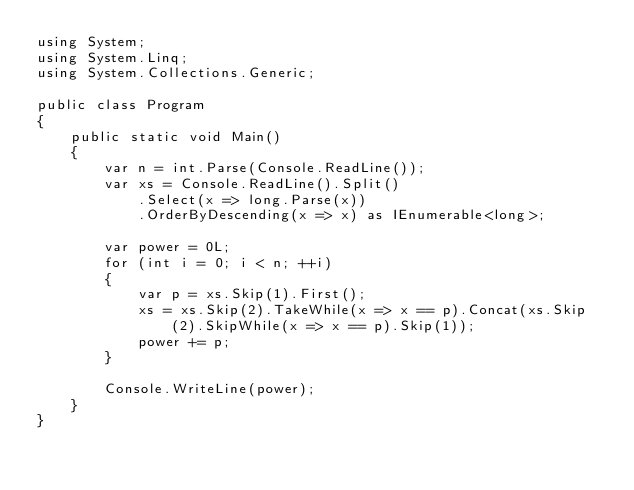<code> <loc_0><loc_0><loc_500><loc_500><_C#_>using System;
using System.Linq;
using System.Collections.Generic;

public class Program
{
    public static void Main()
    {
        var n = int.Parse(Console.ReadLine());
        var xs = Console.ReadLine().Split()
            .Select(x => long.Parse(x))
            .OrderByDescending(x => x) as IEnumerable<long>;

        var power = 0L;
        for (int i = 0; i < n; ++i)
        {
            var p = xs.Skip(1).First();
            xs = xs.Skip(2).TakeWhile(x => x == p).Concat(xs.Skip(2).SkipWhile(x => x == p).Skip(1));
            power += p;
        }
        
        Console.WriteLine(power);
    }
}
</code> 